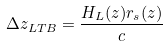Convert formula to latex. <formula><loc_0><loc_0><loc_500><loc_500>\Delta z _ { L T B } = \frac { H _ { L } ( z ) r _ { s } ( z ) } { c }</formula> 